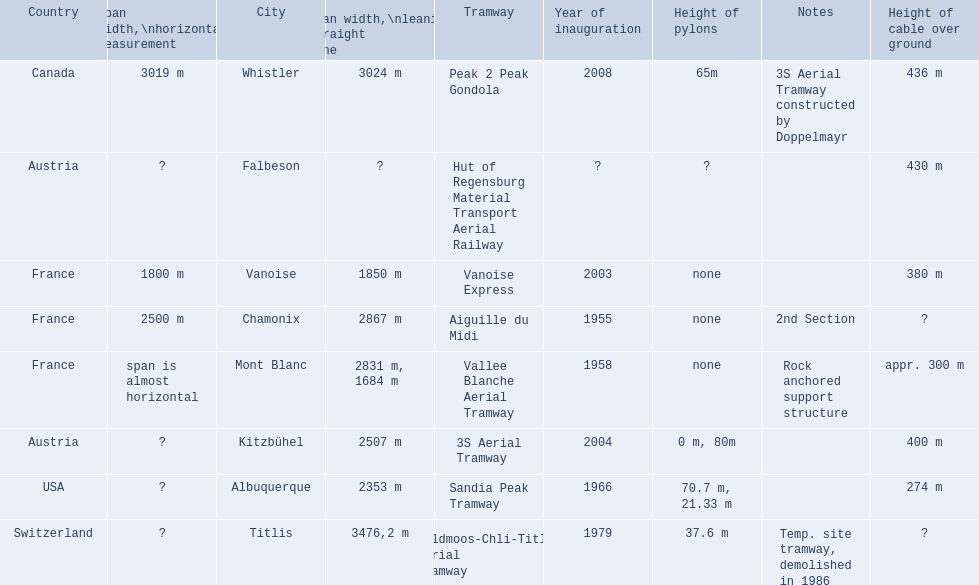When was the aiguille du midi tramway inaugurated? 1955. When was the 3s aerial tramway inaugurated? 2004. Which one was inaugurated first? Aiguille du Midi. 